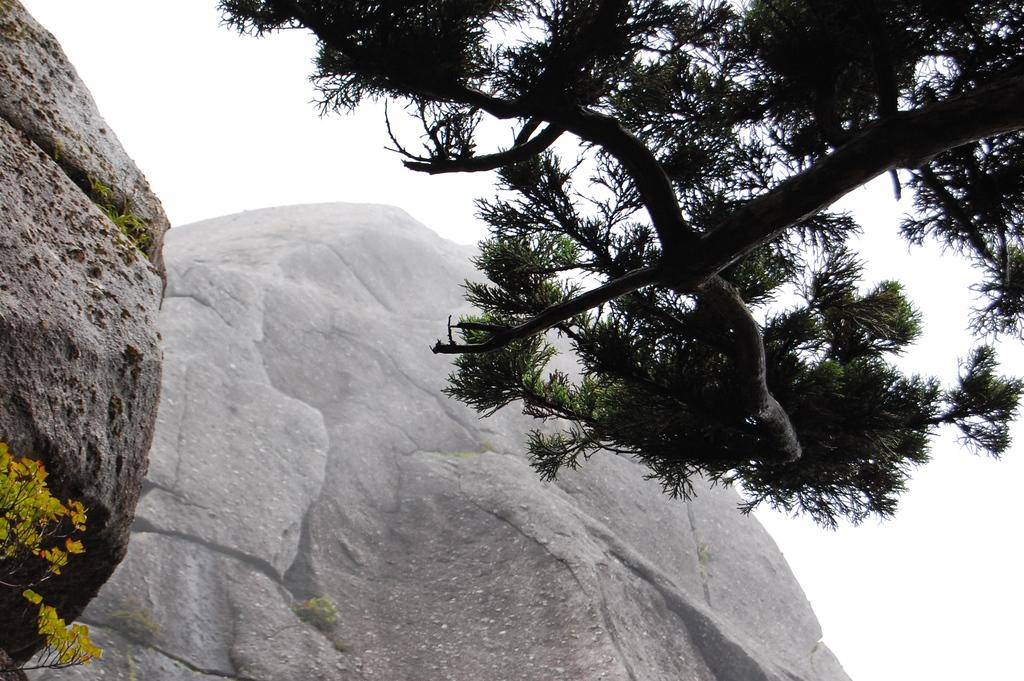What is the main subject in the foreground of the image? There is a tree in the image, and it is in the front of the image. What can be seen in the background of the image? Hills are visible in the background of the image. What is visible above the tree and hills in the image? The sky is visible above the tree and hills in the image. Where is the hospital located in the image? There is no hospital present in the image. Can you tell me how many parents are visible in the image? There are no people, including parents, present in the image. 